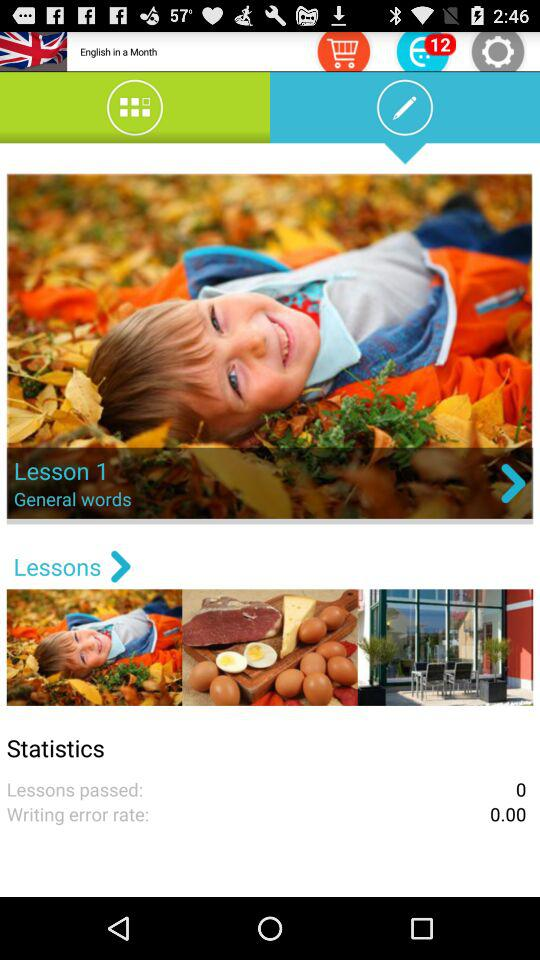What is the lesson number? The lesson number is 1. 